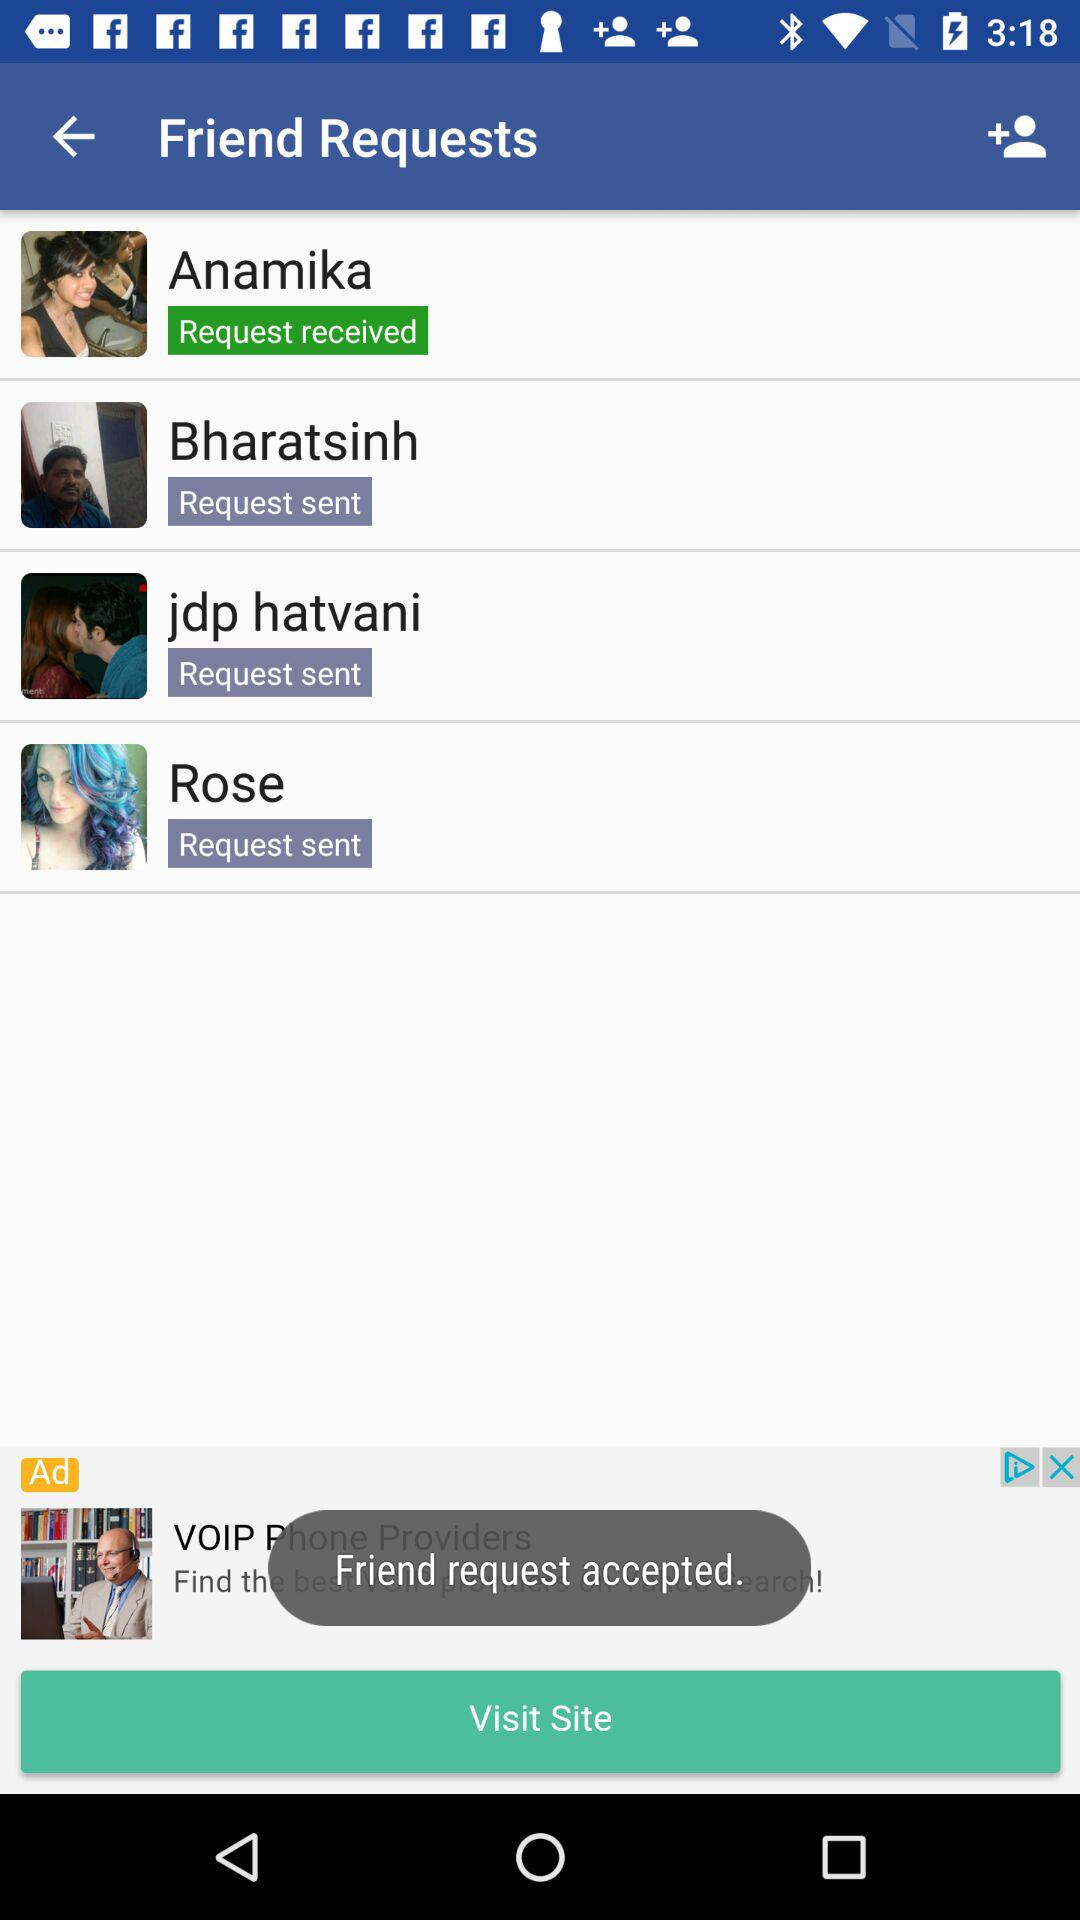How many friend requests have been sent?
Answer the question using a single word or phrase. 3 